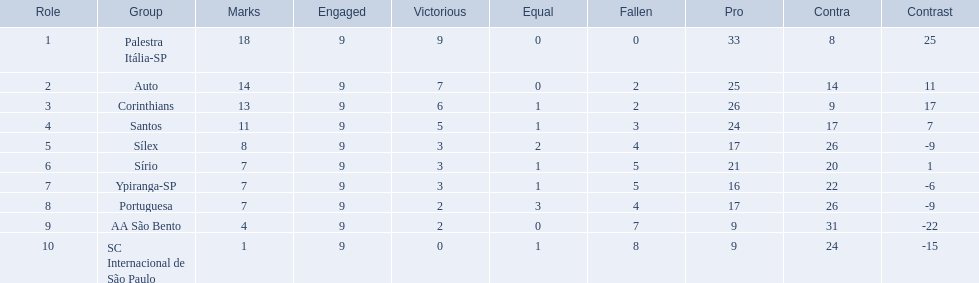What were all the teams that competed in 1926 brazilian football? Palestra Itália-SP, Auto, Corinthians, Santos, Sílex, Sírio, Ypiranga-SP, Portuguesa, AA São Bento, SC Internacional de São Paulo. Which of these had zero games lost? Palestra Itália-SP. 